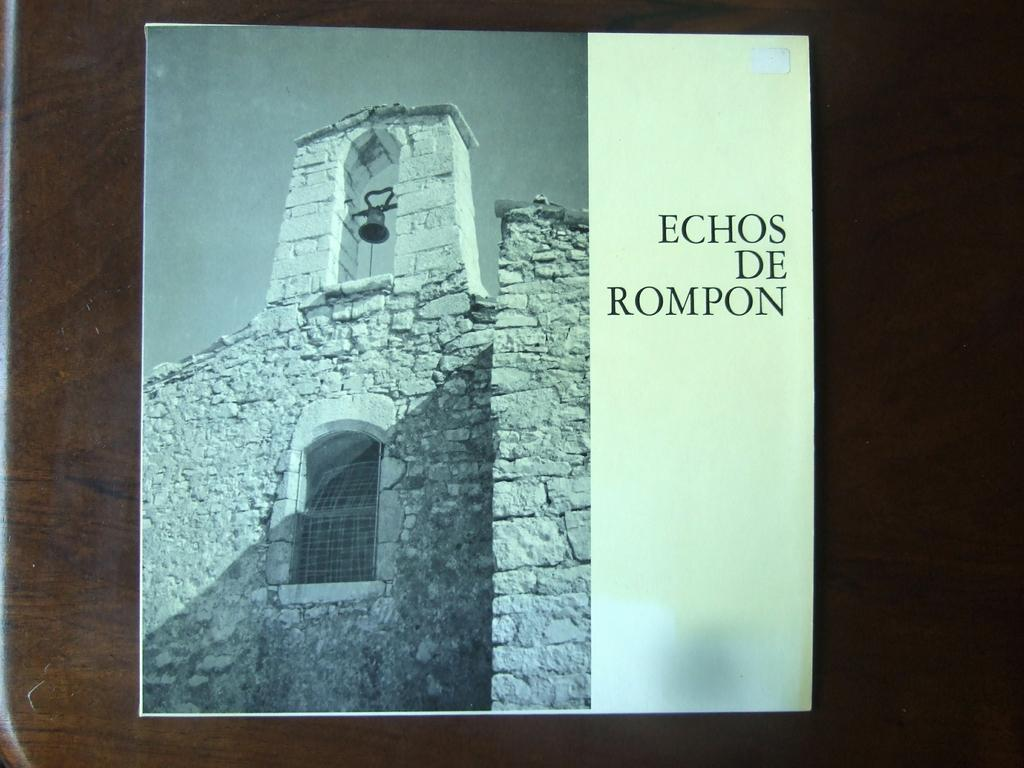Provide a one-sentence caption for the provided image. A poster for Echos De Rompon sits on a wooden table. 